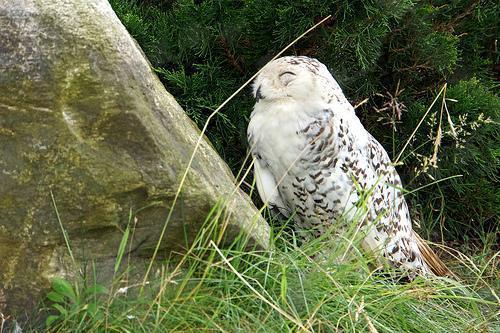How many owls are shown?
Give a very brief answer. 1. 